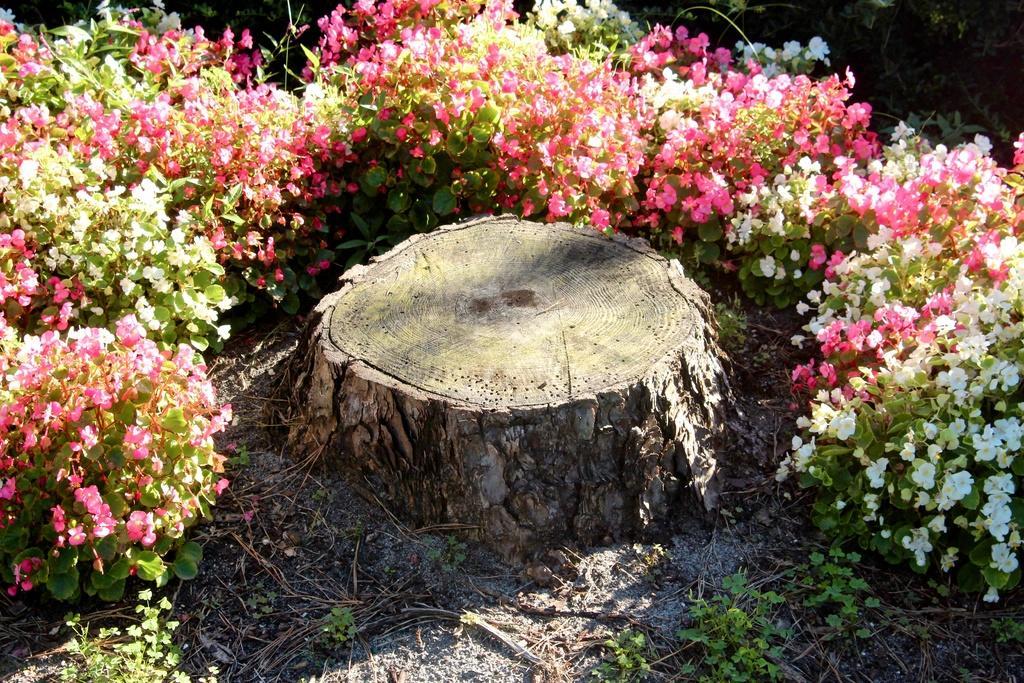Could you give a brief overview of what you see in this image? In this image there are some flowers and plants at the bottom there is some dry grass and in the center there is a tree. 